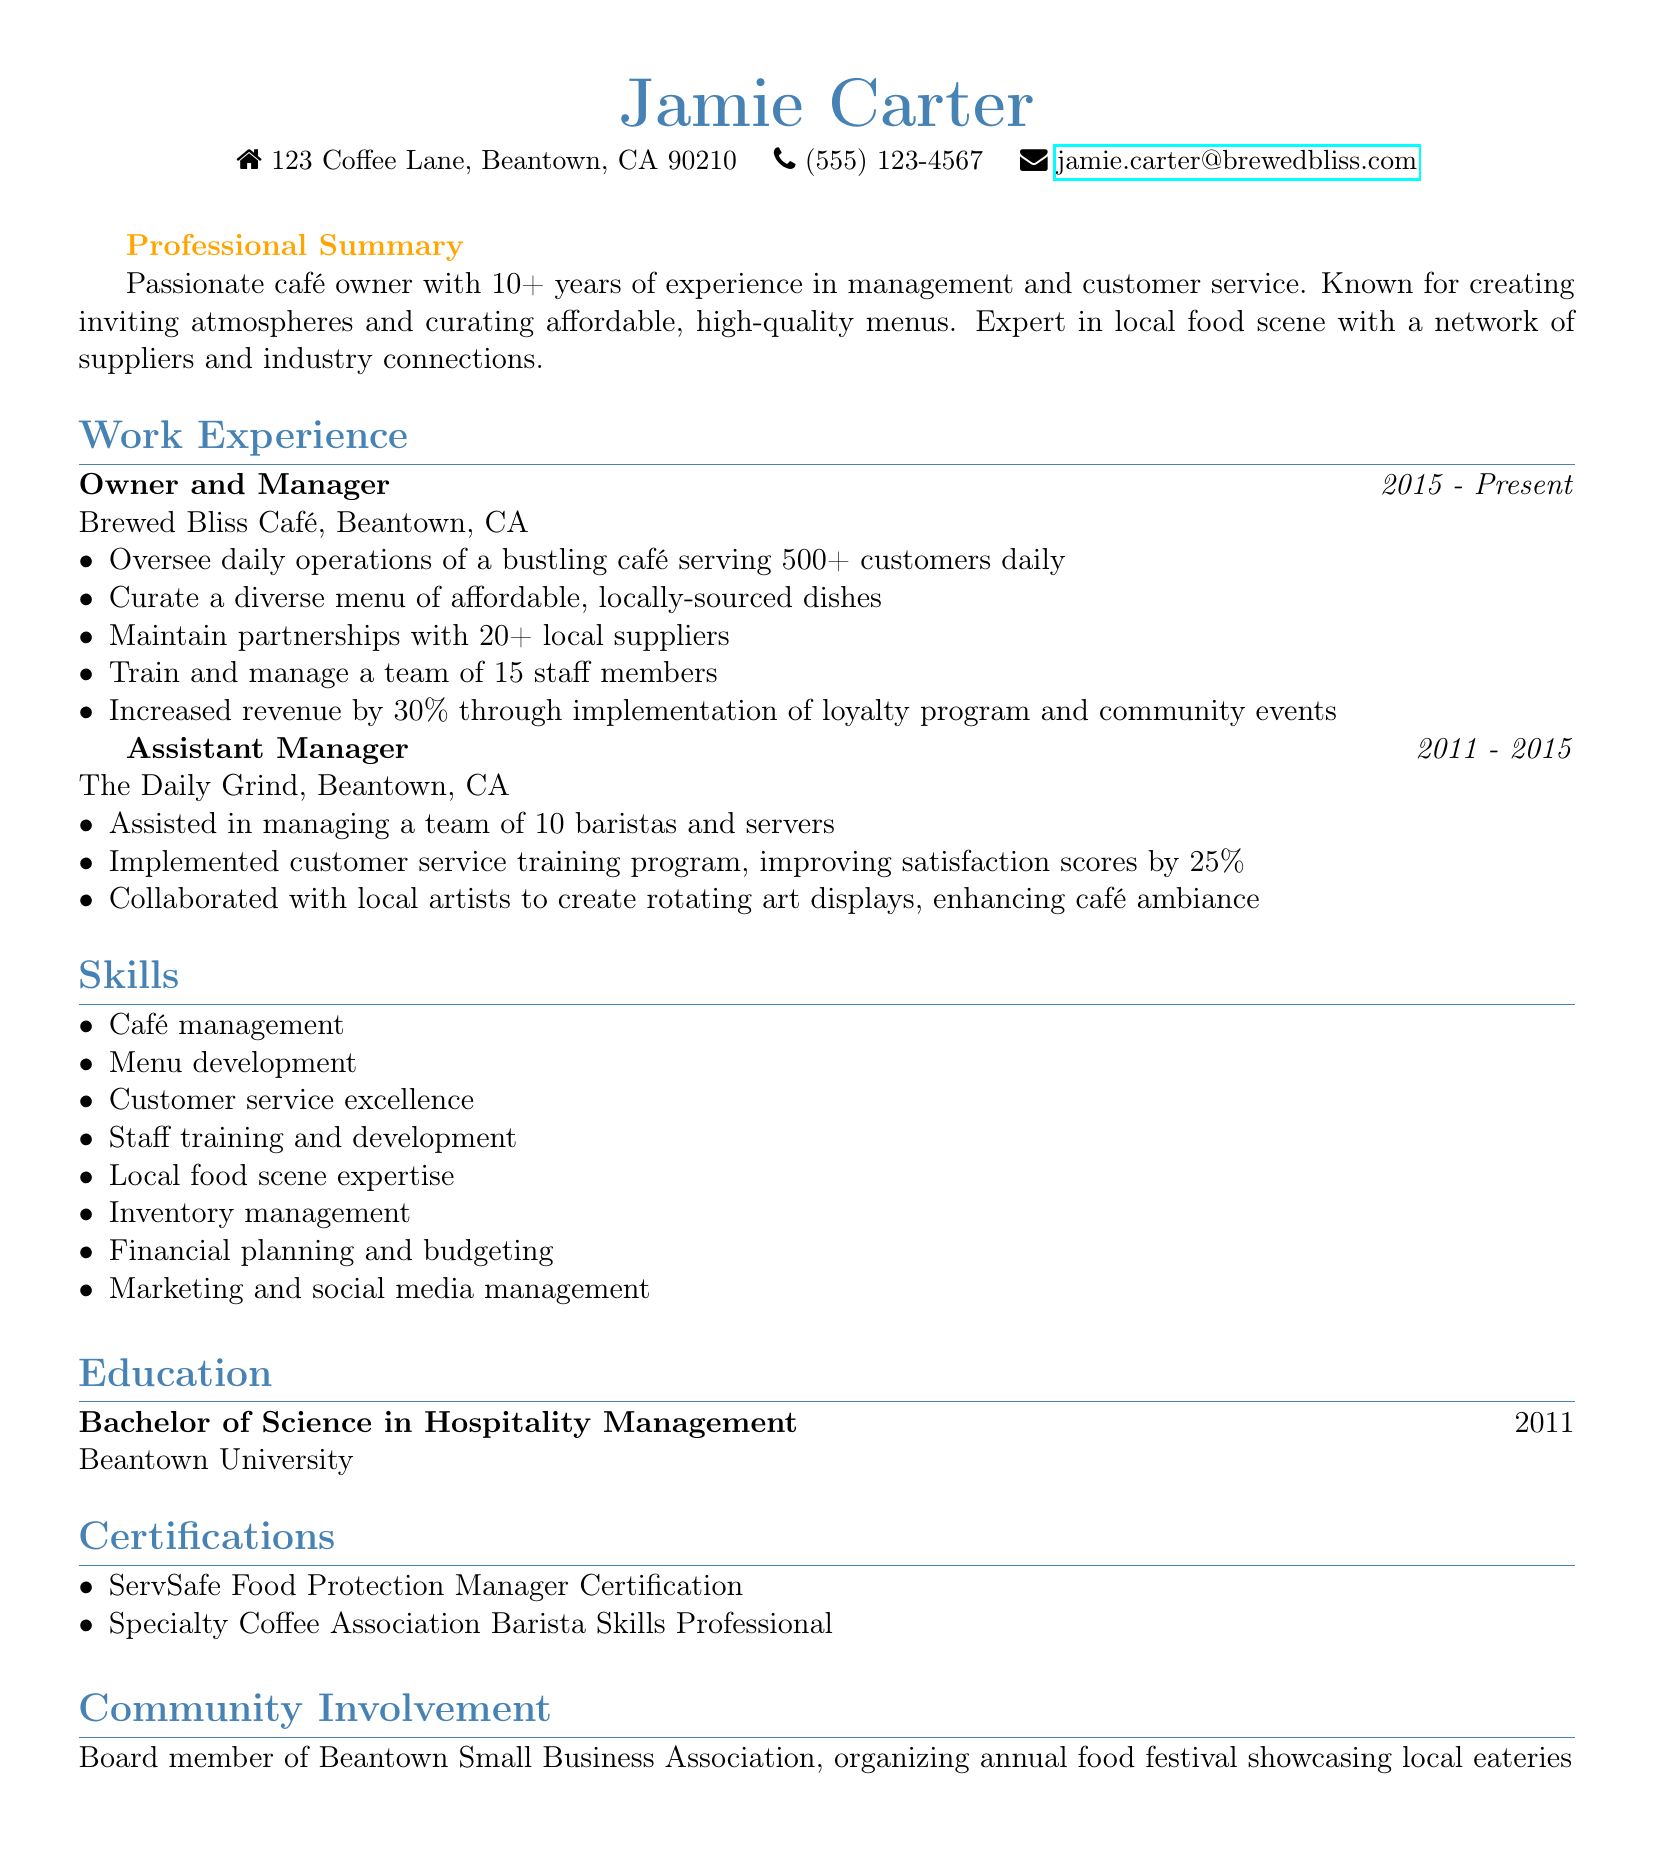What is the name of the café owned by Jamie Carter? The document lists the café owned by Jamie Carter as Brewed Bliss Café.
Answer: Brewed Bliss Café How many years of experience does Jamie have in café management? The professional summary indicates that Jamie has over 10 years of experience in this field.
Answer: 10+ What percentage did Jamie increase revenue by through the loyalty program? In the work experience section, it's mentioned that Jamie increased revenue by 30% through the loyalty program.
Answer: 30% What is the degree earned by Jamie? The education section states that Jamie earned a Bachelor of Science in Hospitality Management.
Answer: Bachelor of Science in Hospitality Management How many staff members does Jamie manage at Brewed Bliss Café? In the work experience section, it's specified that Jamie manages a team of 15 staff members.
Answer: 15 What type of certification does Jamie have related to food safety? The certifications section lists the ServSafe Food Protection Manager Certification as one of Jamie’s qualifications.
Answer: ServSafe Food Protection Manager Certification What project did Jamie collaborate on to enhance the café's ambiance while at The Daily Grind? The work experience of Jamie mentions collaborating with local artists to create rotating art displays for ambiance.
Answer: Rotating art displays What community role does Jamie hold? The community involvement section states that Jamie is a board member of the Beantown Small Business Association.
Answer: Board member of Beantown Small Business Association 